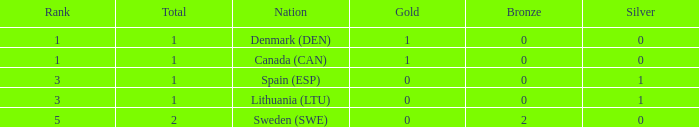What is the number of gold medals for Lithuania (ltu), when the total is more than 1? None. 